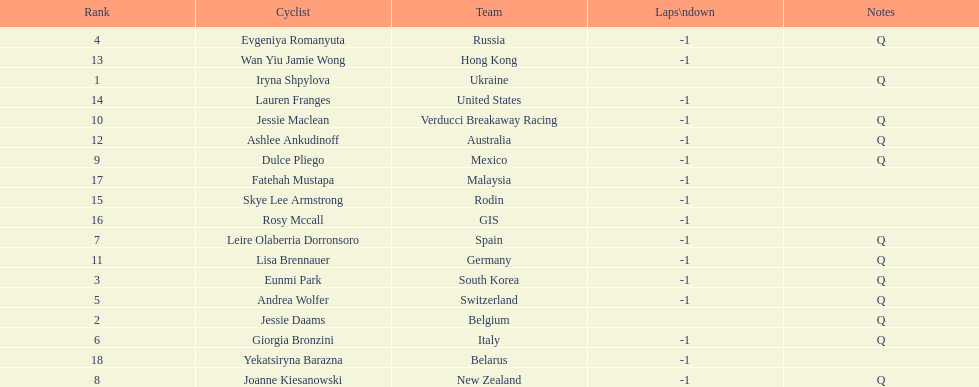What is the number rank of belgium? 2. 